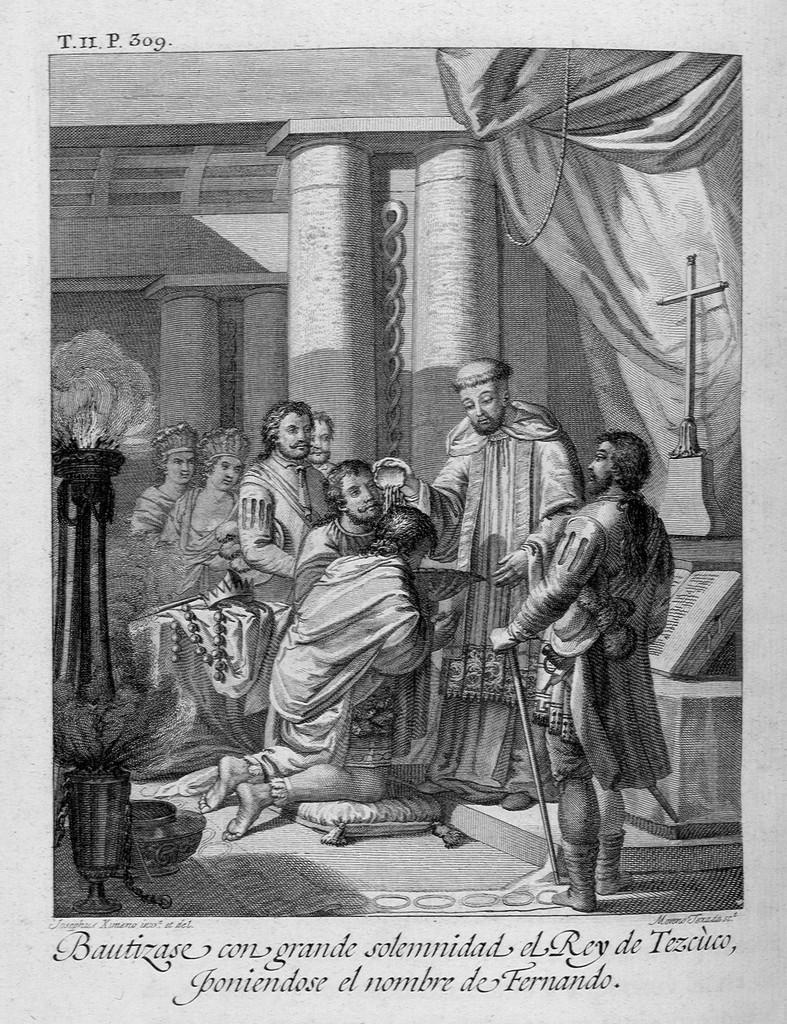In one or two sentences, can you explain what this image depicts? This is a black white painting. In it there are many people. Here there are flower pots. These are pillars. At the bottom few texts are there. 